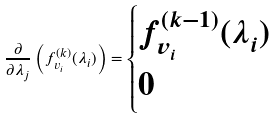Convert formula to latex. <formula><loc_0><loc_0><loc_500><loc_500>\frac { \partial } { \partial \lambda _ { j } } \left ( f _ { v _ { i } } ^ { ( k ) } ( \lambda _ { i } ) \right ) = \begin{cases} f _ { v _ { i } } ^ { ( k - 1 ) } ( \lambda _ { i } ) & \\ 0 & \end{cases}</formula> 